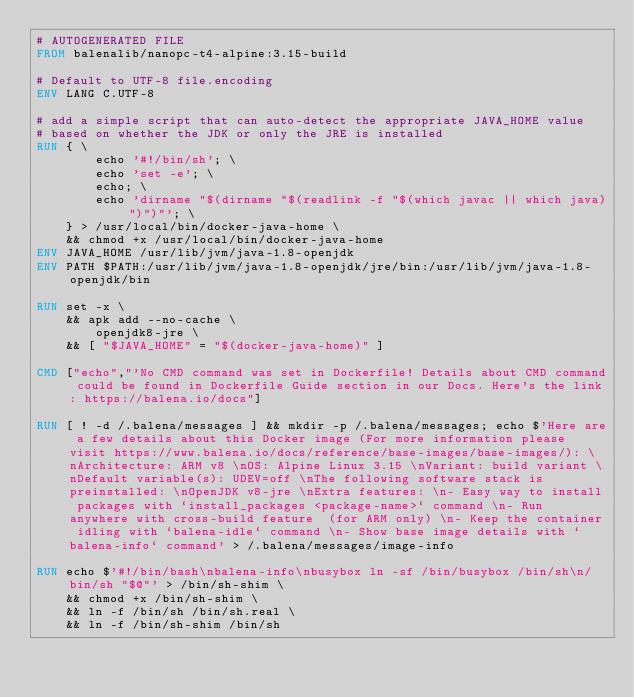<code> <loc_0><loc_0><loc_500><loc_500><_Dockerfile_># AUTOGENERATED FILE
FROM balenalib/nanopc-t4-alpine:3.15-build

# Default to UTF-8 file.encoding
ENV LANG C.UTF-8

# add a simple script that can auto-detect the appropriate JAVA_HOME value
# based on whether the JDK or only the JRE is installed
RUN { \
		echo '#!/bin/sh'; \
		echo 'set -e'; \
		echo; \
		echo 'dirname "$(dirname "$(readlink -f "$(which javac || which java)")")"'; \
	} > /usr/local/bin/docker-java-home \
	&& chmod +x /usr/local/bin/docker-java-home
ENV JAVA_HOME /usr/lib/jvm/java-1.8-openjdk
ENV PATH $PATH:/usr/lib/jvm/java-1.8-openjdk/jre/bin:/usr/lib/jvm/java-1.8-openjdk/bin

RUN set -x \
	&& apk add --no-cache \
		openjdk8-jre \
	&& [ "$JAVA_HOME" = "$(docker-java-home)" ]

CMD ["echo","'No CMD command was set in Dockerfile! Details about CMD command could be found in Dockerfile Guide section in our Docs. Here's the link: https://balena.io/docs"]

RUN [ ! -d /.balena/messages ] && mkdir -p /.balena/messages; echo $'Here are a few details about this Docker image (For more information please visit https://www.balena.io/docs/reference/base-images/base-images/): \nArchitecture: ARM v8 \nOS: Alpine Linux 3.15 \nVariant: build variant \nDefault variable(s): UDEV=off \nThe following software stack is preinstalled: \nOpenJDK v8-jre \nExtra features: \n- Easy way to install packages with `install_packages <package-name>` command \n- Run anywhere with cross-build feature  (for ARM only) \n- Keep the container idling with `balena-idle` command \n- Show base image details with `balena-info` command' > /.balena/messages/image-info

RUN echo $'#!/bin/bash\nbalena-info\nbusybox ln -sf /bin/busybox /bin/sh\n/bin/sh "$@"' > /bin/sh-shim \
	&& chmod +x /bin/sh-shim \
	&& ln -f /bin/sh /bin/sh.real \
	&& ln -f /bin/sh-shim /bin/sh</code> 